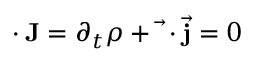<formula> <loc_0><loc_0><loc_500><loc_500>\partial \cdot J = \partial _ { t } \rho + { \vec { \nabla } } \cdot { \vec { j } } = 0</formula> 